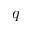Convert formula to latex. <formula><loc_0><loc_0><loc_500><loc_500>q</formula> 